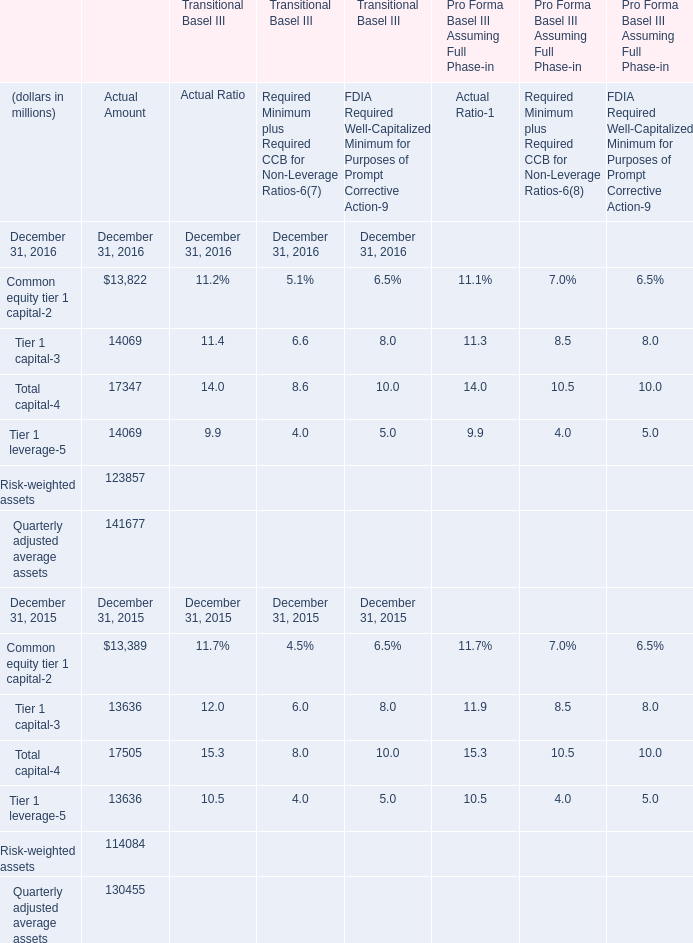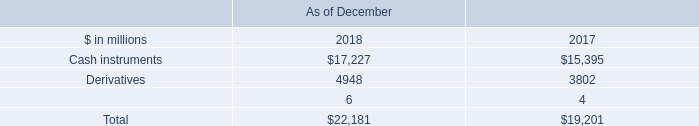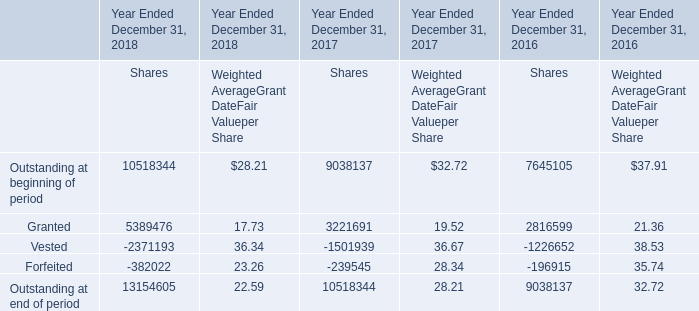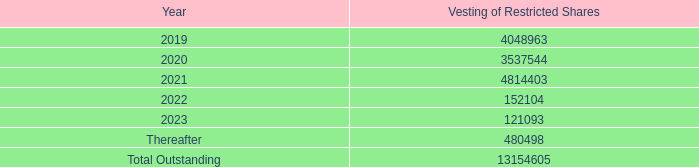In the year with largest amount of Common equity tier 1 capital, what's the sum of Actual Amount? (in million) 
Computations: (((((13822 + 14069) + 17347) + 14069) + 123857) + 141677)
Answer: 324841.0. 